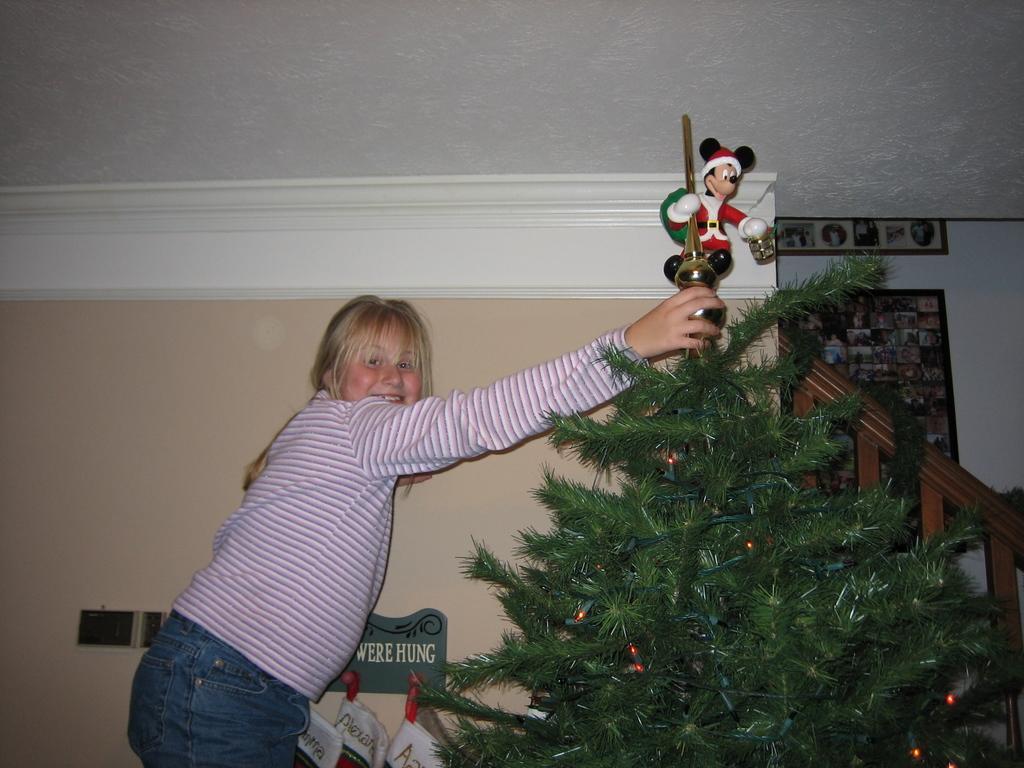Please provide a concise description of this image. In the image there is a girl in pink and white striped t-shirt holding christmas tree, in the back there is a staircase, there is a mickey mouse above the tree. 